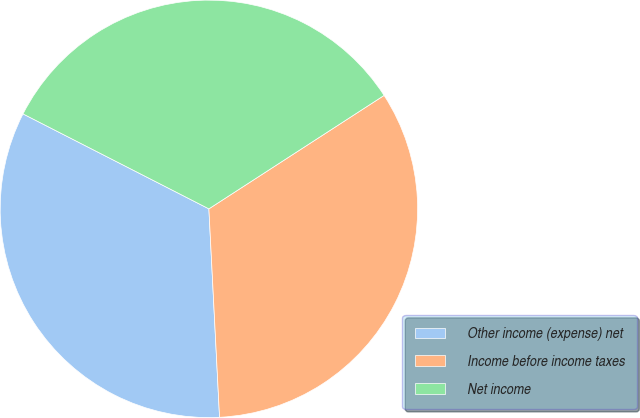Convert chart to OTSL. <chart><loc_0><loc_0><loc_500><loc_500><pie_chart><fcel>Other income (expense) net<fcel>Income before income taxes<fcel>Net income<nl><fcel>33.33%<fcel>33.33%<fcel>33.34%<nl></chart> 